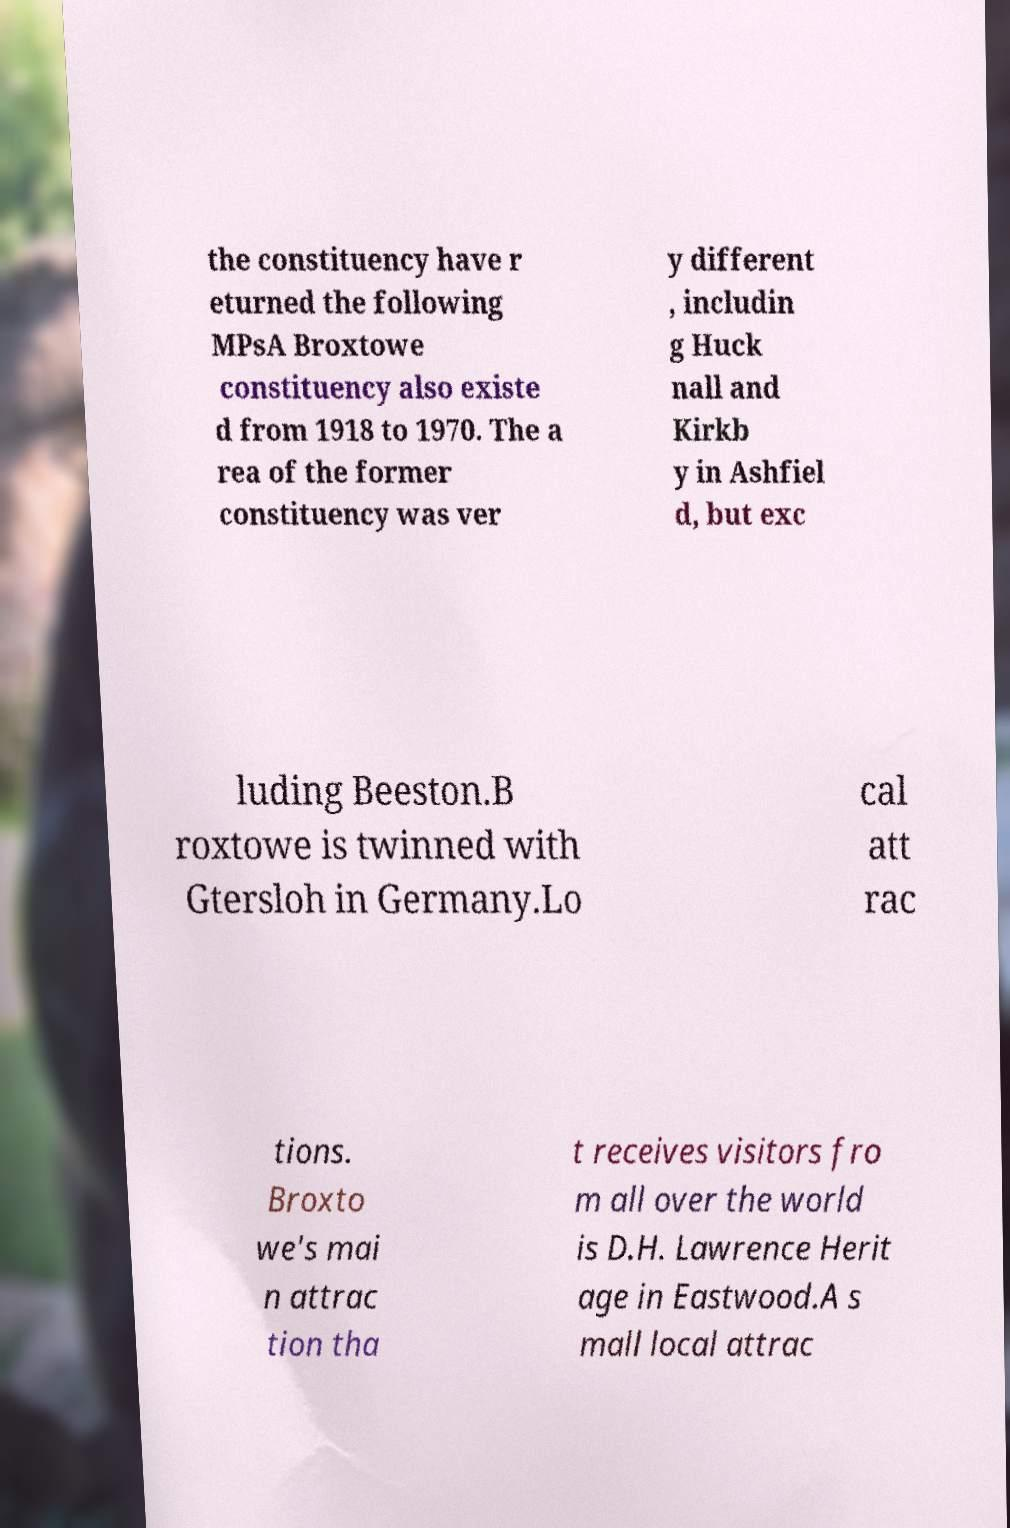I need the written content from this picture converted into text. Can you do that? the constituency have r eturned the following MPsA Broxtowe constituency also existe d from 1918 to 1970. The a rea of the former constituency was ver y different , includin g Huck nall and Kirkb y in Ashfiel d, but exc luding Beeston.B roxtowe is twinned with Gtersloh in Germany.Lo cal att rac tions. Broxto we's mai n attrac tion tha t receives visitors fro m all over the world is D.H. Lawrence Herit age in Eastwood.A s mall local attrac 